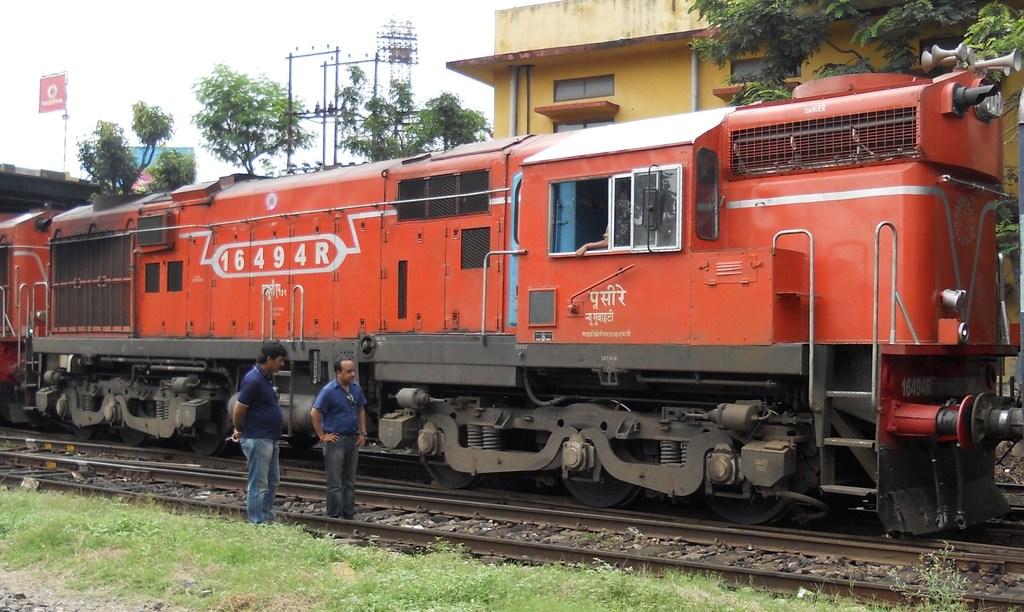What's the train number?
Keep it short and to the point. 16494r. 